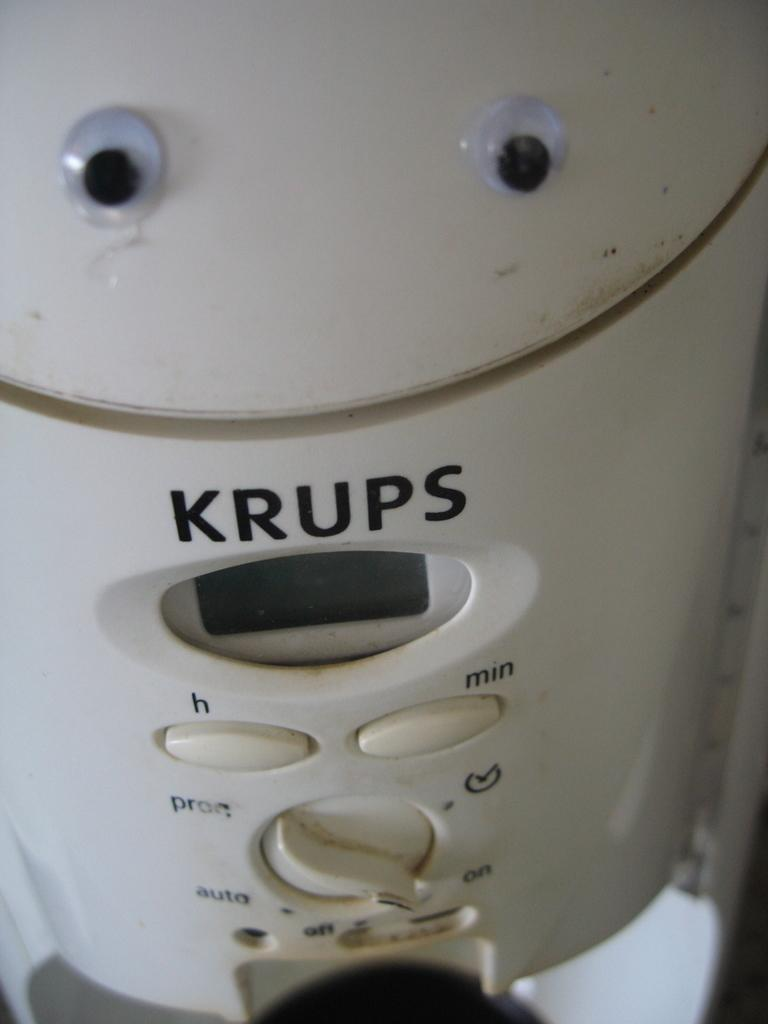<image>
Share a concise interpretation of the image provided. Someone has placed google eyes on a white Krups appliance. 